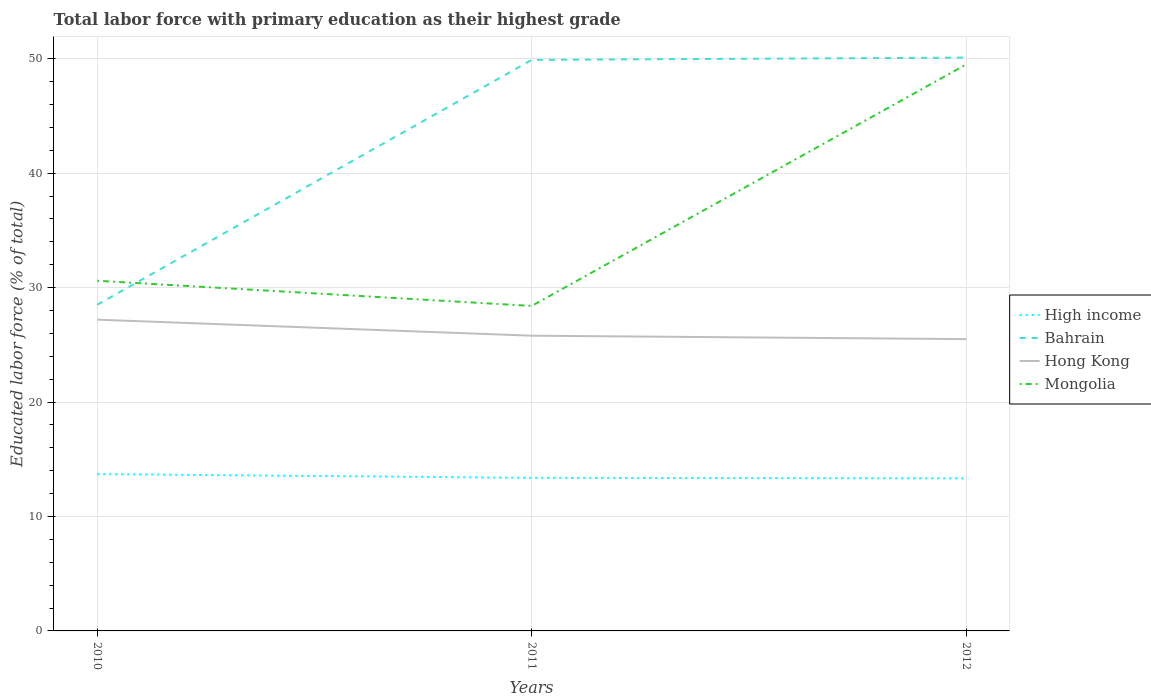How many different coloured lines are there?
Provide a succinct answer. 4. Does the line corresponding to Mongolia intersect with the line corresponding to Bahrain?
Offer a very short reply. Yes. In which year was the percentage of total labor force with primary education in High income maximum?
Provide a succinct answer. 2012. What is the total percentage of total labor force with primary education in Bahrain in the graph?
Your response must be concise. -21.4. What is the difference between the highest and the second highest percentage of total labor force with primary education in Bahrain?
Make the answer very short. 21.6. How many lines are there?
Your response must be concise. 4. What is the title of the graph?
Provide a succinct answer. Total labor force with primary education as their highest grade. Does "Moldova" appear as one of the legend labels in the graph?
Your answer should be compact. No. What is the label or title of the X-axis?
Your answer should be very brief. Years. What is the label or title of the Y-axis?
Give a very brief answer. Educated labor force (% of total). What is the Educated labor force (% of total) in High income in 2010?
Provide a succinct answer. 13.7. What is the Educated labor force (% of total) in Bahrain in 2010?
Your response must be concise. 28.5. What is the Educated labor force (% of total) of Hong Kong in 2010?
Give a very brief answer. 27.2. What is the Educated labor force (% of total) of Mongolia in 2010?
Your answer should be very brief. 30.6. What is the Educated labor force (% of total) in High income in 2011?
Give a very brief answer. 13.38. What is the Educated labor force (% of total) of Bahrain in 2011?
Keep it short and to the point. 49.9. What is the Educated labor force (% of total) of Hong Kong in 2011?
Make the answer very short. 25.8. What is the Educated labor force (% of total) of Mongolia in 2011?
Give a very brief answer. 28.4. What is the Educated labor force (% of total) of High income in 2012?
Your answer should be compact. 13.33. What is the Educated labor force (% of total) in Bahrain in 2012?
Your response must be concise. 50.1. What is the Educated labor force (% of total) of Hong Kong in 2012?
Your answer should be very brief. 25.5. What is the Educated labor force (% of total) of Mongolia in 2012?
Give a very brief answer. 49.5. Across all years, what is the maximum Educated labor force (% of total) of High income?
Offer a very short reply. 13.7. Across all years, what is the maximum Educated labor force (% of total) of Bahrain?
Make the answer very short. 50.1. Across all years, what is the maximum Educated labor force (% of total) of Hong Kong?
Your answer should be compact. 27.2. Across all years, what is the maximum Educated labor force (% of total) of Mongolia?
Make the answer very short. 49.5. Across all years, what is the minimum Educated labor force (% of total) of High income?
Ensure brevity in your answer.  13.33. Across all years, what is the minimum Educated labor force (% of total) in Hong Kong?
Your answer should be very brief. 25.5. Across all years, what is the minimum Educated labor force (% of total) of Mongolia?
Offer a terse response. 28.4. What is the total Educated labor force (% of total) of High income in the graph?
Give a very brief answer. 40.41. What is the total Educated labor force (% of total) of Bahrain in the graph?
Keep it short and to the point. 128.5. What is the total Educated labor force (% of total) of Hong Kong in the graph?
Make the answer very short. 78.5. What is the total Educated labor force (% of total) in Mongolia in the graph?
Offer a terse response. 108.5. What is the difference between the Educated labor force (% of total) in High income in 2010 and that in 2011?
Your response must be concise. 0.33. What is the difference between the Educated labor force (% of total) of Bahrain in 2010 and that in 2011?
Your response must be concise. -21.4. What is the difference between the Educated labor force (% of total) in Hong Kong in 2010 and that in 2011?
Your answer should be compact. 1.4. What is the difference between the Educated labor force (% of total) in Mongolia in 2010 and that in 2011?
Your response must be concise. 2.2. What is the difference between the Educated labor force (% of total) in High income in 2010 and that in 2012?
Offer a very short reply. 0.37. What is the difference between the Educated labor force (% of total) of Bahrain in 2010 and that in 2012?
Give a very brief answer. -21.6. What is the difference between the Educated labor force (% of total) of Mongolia in 2010 and that in 2012?
Provide a succinct answer. -18.9. What is the difference between the Educated labor force (% of total) of High income in 2011 and that in 2012?
Your response must be concise. 0.05. What is the difference between the Educated labor force (% of total) of Mongolia in 2011 and that in 2012?
Offer a terse response. -21.1. What is the difference between the Educated labor force (% of total) of High income in 2010 and the Educated labor force (% of total) of Bahrain in 2011?
Ensure brevity in your answer.  -36.2. What is the difference between the Educated labor force (% of total) of High income in 2010 and the Educated labor force (% of total) of Hong Kong in 2011?
Keep it short and to the point. -12.1. What is the difference between the Educated labor force (% of total) in High income in 2010 and the Educated labor force (% of total) in Mongolia in 2011?
Offer a very short reply. -14.7. What is the difference between the Educated labor force (% of total) in Bahrain in 2010 and the Educated labor force (% of total) in Mongolia in 2011?
Make the answer very short. 0.1. What is the difference between the Educated labor force (% of total) of Hong Kong in 2010 and the Educated labor force (% of total) of Mongolia in 2011?
Keep it short and to the point. -1.2. What is the difference between the Educated labor force (% of total) of High income in 2010 and the Educated labor force (% of total) of Bahrain in 2012?
Keep it short and to the point. -36.4. What is the difference between the Educated labor force (% of total) in High income in 2010 and the Educated labor force (% of total) in Hong Kong in 2012?
Give a very brief answer. -11.8. What is the difference between the Educated labor force (% of total) in High income in 2010 and the Educated labor force (% of total) in Mongolia in 2012?
Your answer should be very brief. -35.8. What is the difference between the Educated labor force (% of total) in Bahrain in 2010 and the Educated labor force (% of total) in Hong Kong in 2012?
Provide a short and direct response. 3. What is the difference between the Educated labor force (% of total) in Hong Kong in 2010 and the Educated labor force (% of total) in Mongolia in 2012?
Ensure brevity in your answer.  -22.3. What is the difference between the Educated labor force (% of total) in High income in 2011 and the Educated labor force (% of total) in Bahrain in 2012?
Offer a very short reply. -36.72. What is the difference between the Educated labor force (% of total) in High income in 2011 and the Educated labor force (% of total) in Hong Kong in 2012?
Offer a terse response. -12.12. What is the difference between the Educated labor force (% of total) of High income in 2011 and the Educated labor force (% of total) of Mongolia in 2012?
Provide a short and direct response. -36.12. What is the difference between the Educated labor force (% of total) of Bahrain in 2011 and the Educated labor force (% of total) of Hong Kong in 2012?
Keep it short and to the point. 24.4. What is the difference between the Educated labor force (% of total) of Hong Kong in 2011 and the Educated labor force (% of total) of Mongolia in 2012?
Give a very brief answer. -23.7. What is the average Educated labor force (% of total) of High income per year?
Provide a short and direct response. 13.47. What is the average Educated labor force (% of total) in Bahrain per year?
Keep it short and to the point. 42.83. What is the average Educated labor force (% of total) of Hong Kong per year?
Ensure brevity in your answer.  26.17. What is the average Educated labor force (% of total) of Mongolia per year?
Offer a terse response. 36.17. In the year 2010, what is the difference between the Educated labor force (% of total) in High income and Educated labor force (% of total) in Bahrain?
Ensure brevity in your answer.  -14.8. In the year 2010, what is the difference between the Educated labor force (% of total) of High income and Educated labor force (% of total) of Hong Kong?
Your answer should be compact. -13.5. In the year 2010, what is the difference between the Educated labor force (% of total) in High income and Educated labor force (% of total) in Mongolia?
Your answer should be compact. -16.9. In the year 2010, what is the difference between the Educated labor force (% of total) of Bahrain and Educated labor force (% of total) of Mongolia?
Your answer should be very brief. -2.1. In the year 2011, what is the difference between the Educated labor force (% of total) in High income and Educated labor force (% of total) in Bahrain?
Provide a succinct answer. -36.52. In the year 2011, what is the difference between the Educated labor force (% of total) of High income and Educated labor force (% of total) of Hong Kong?
Make the answer very short. -12.42. In the year 2011, what is the difference between the Educated labor force (% of total) in High income and Educated labor force (% of total) in Mongolia?
Offer a very short reply. -15.02. In the year 2011, what is the difference between the Educated labor force (% of total) of Bahrain and Educated labor force (% of total) of Hong Kong?
Provide a short and direct response. 24.1. In the year 2011, what is the difference between the Educated labor force (% of total) of Bahrain and Educated labor force (% of total) of Mongolia?
Offer a very short reply. 21.5. In the year 2012, what is the difference between the Educated labor force (% of total) of High income and Educated labor force (% of total) of Bahrain?
Offer a terse response. -36.77. In the year 2012, what is the difference between the Educated labor force (% of total) of High income and Educated labor force (% of total) of Hong Kong?
Offer a very short reply. -12.17. In the year 2012, what is the difference between the Educated labor force (% of total) in High income and Educated labor force (% of total) in Mongolia?
Keep it short and to the point. -36.17. In the year 2012, what is the difference between the Educated labor force (% of total) in Bahrain and Educated labor force (% of total) in Hong Kong?
Give a very brief answer. 24.6. In the year 2012, what is the difference between the Educated labor force (% of total) of Bahrain and Educated labor force (% of total) of Mongolia?
Your response must be concise. 0.6. What is the ratio of the Educated labor force (% of total) in High income in 2010 to that in 2011?
Your response must be concise. 1.02. What is the ratio of the Educated labor force (% of total) in Bahrain in 2010 to that in 2011?
Provide a succinct answer. 0.57. What is the ratio of the Educated labor force (% of total) of Hong Kong in 2010 to that in 2011?
Give a very brief answer. 1.05. What is the ratio of the Educated labor force (% of total) of Mongolia in 2010 to that in 2011?
Provide a short and direct response. 1.08. What is the ratio of the Educated labor force (% of total) in High income in 2010 to that in 2012?
Provide a short and direct response. 1.03. What is the ratio of the Educated labor force (% of total) of Bahrain in 2010 to that in 2012?
Offer a terse response. 0.57. What is the ratio of the Educated labor force (% of total) in Hong Kong in 2010 to that in 2012?
Make the answer very short. 1.07. What is the ratio of the Educated labor force (% of total) in Mongolia in 2010 to that in 2012?
Keep it short and to the point. 0.62. What is the ratio of the Educated labor force (% of total) of High income in 2011 to that in 2012?
Keep it short and to the point. 1. What is the ratio of the Educated labor force (% of total) of Hong Kong in 2011 to that in 2012?
Offer a terse response. 1.01. What is the ratio of the Educated labor force (% of total) of Mongolia in 2011 to that in 2012?
Your response must be concise. 0.57. What is the difference between the highest and the second highest Educated labor force (% of total) of High income?
Your response must be concise. 0.33. What is the difference between the highest and the lowest Educated labor force (% of total) in High income?
Give a very brief answer. 0.37. What is the difference between the highest and the lowest Educated labor force (% of total) in Bahrain?
Provide a short and direct response. 21.6. What is the difference between the highest and the lowest Educated labor force (% of total) in Mongolia?
Give a very brief answer. 21.1. 